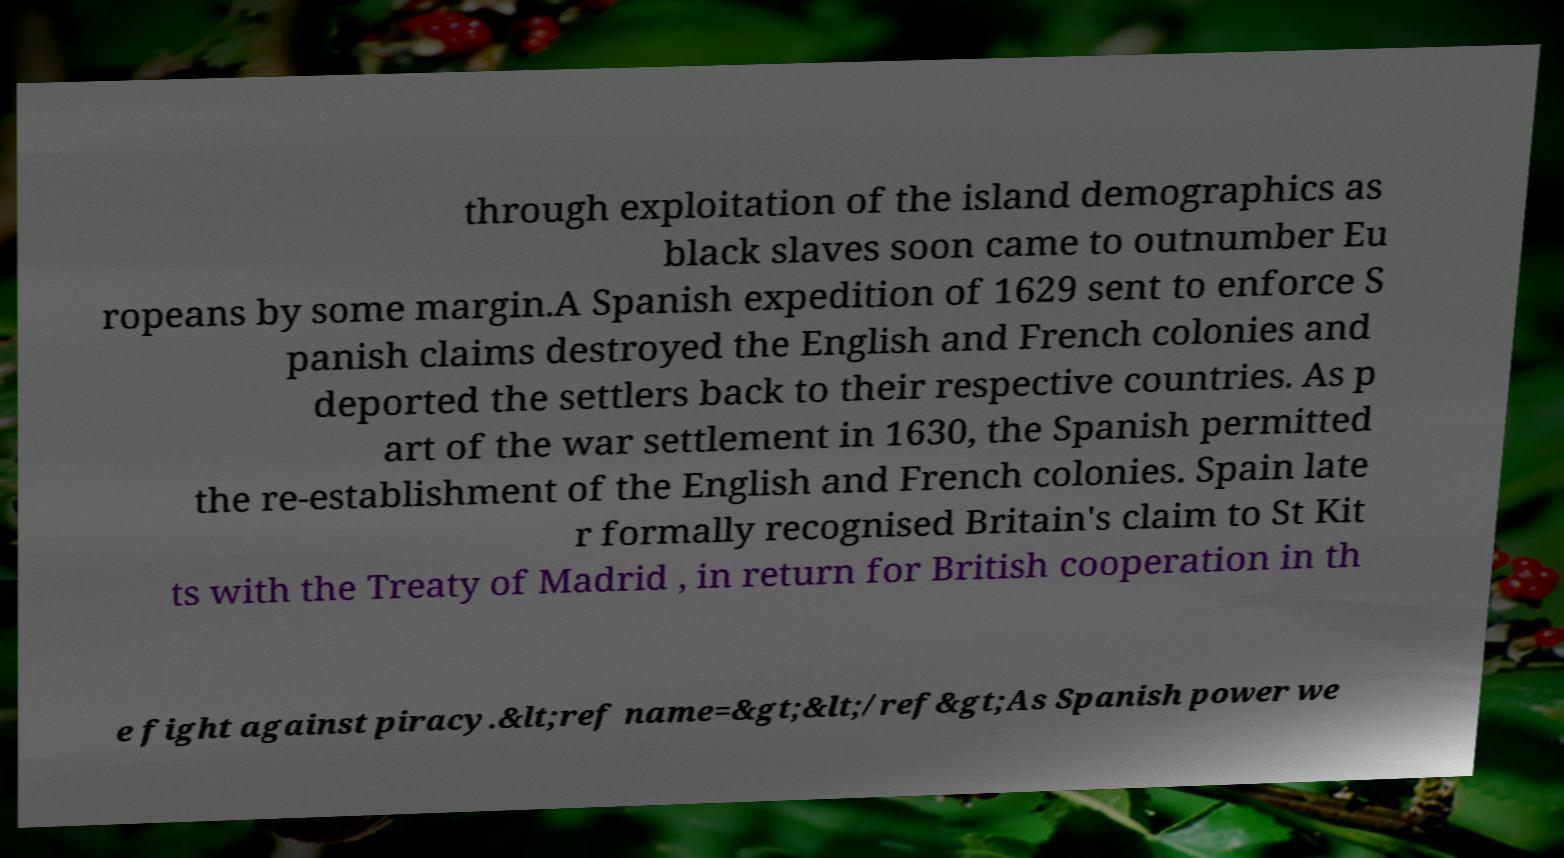Could you assist in decoding the text presented in this image and type it out clearly? through exploitation of the island demographics as black slaves soon came to outnumber Eu ropeans by some margin.A Spanish expedition of 1629 sent to enforce S panish claims destroyed the English and French colonies and deported the settlers back to their respective countries. As p art of the war settlement in 1630, the Spanish permitted the re-establishment of the English and French colonies. Spain late r formally recognised Britain's claim to St Kit ts with the Treaty of Madrid , in return for British cooperation in th e fight against piracy.&lt;ref name=&gt;&lt;/ref&gt;As Spanish power we 